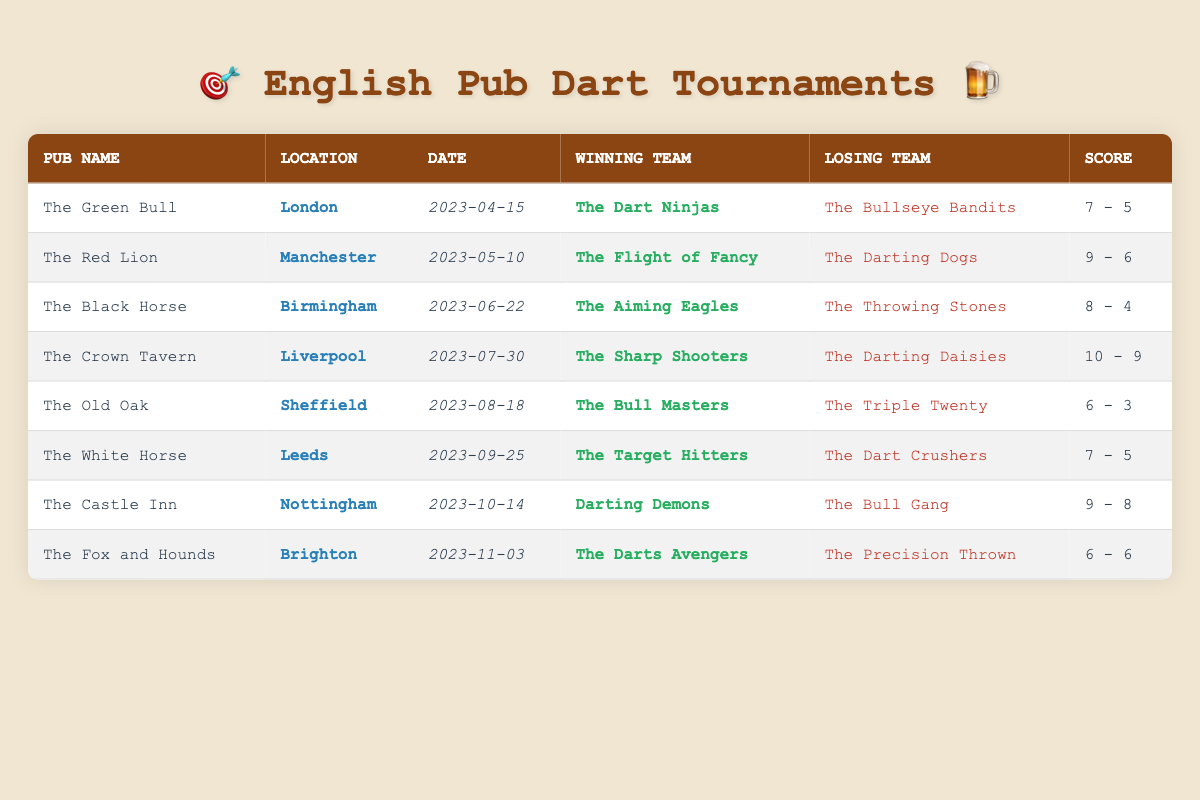What was the winning score for The Green Bull tournament? The winning score for The Green Bull tournament can be found in the table under the "Score" column for that row. It shows 7 for The Dart Ninjas against The Bullseye Bandits.
Answer: 7 Which team won the tournament in Liverpool? In the Liverpool row, the winning team is listed under "Winning Team." It shows "The Sharp Shooters" in that column.
Answer: The Sharp Shooters What is the total number of tournaments played in Sheffield? There is only one entry for Sheffield in the table. By counting the rows, we can see that only one tournament is listed for The Old Oak.
Answer: 1 Did The Flight of Fancy win with a score difference of more than 2 points? For the tournament held at The Red Lion, The Flight of Fancy won with a score of 9 and The Darting Dogs scored 6. The difference is 9 - 6 = 3, which is greater than 2. Thus, the statement is true.
Answer: Yes Which pub had the highest total score in its tournament? We can look at the scores in each row and calculate the total scores for each pub. The highest score comes from The Crown Tavern, where the total score is 10 + 9 = 19. Other scores do not exceed this total.
Answer: The Crown Tavern What was the earliest tournament date listed in the table? The tournament dates can be found in the "Date" column. The earliest date in the list appears to be "2023-04-15" for The Green Bull.
Answer: 2023-04-15 Was there a tournament where both teams scored the same points? The only tournament with equal scores is The Fox and Hounds, where both teams scored 6. Therefore, yes, this statement is true.
Answer: Yes What is the average winning score across all tournaments? To find the average winning score, sum up all winning scores (7 + 9 + 8 + 10 + 6 + 7 + 9 + 6) which equals 62. There are 8 tournaments, so the average is 62/8 = 7.75.
Answer: 7.75 Which location had the winning team "Darting Demons"? The table shows that the winning team "Darting Demons" appears in the row for "The Castle Inn," which is in Nottingham.
Answer: Nottingham 